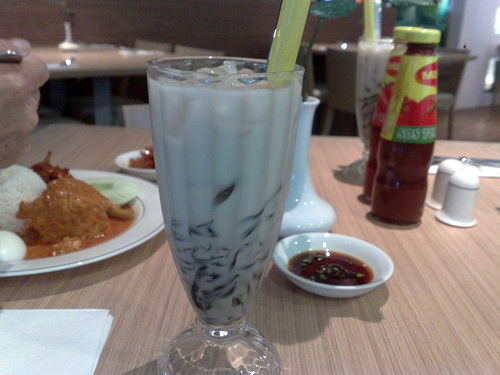<image>
Is the salt shaker in front of the straw? No. The salt shaker is not in front of the straw. The spatial positioning shows a different relationship between these objects. Where is the food in relation to the sauce? Is it to the left of the sauce? Yes. From this viewpoint, the food is positioned to the left side relative to the sauce. 